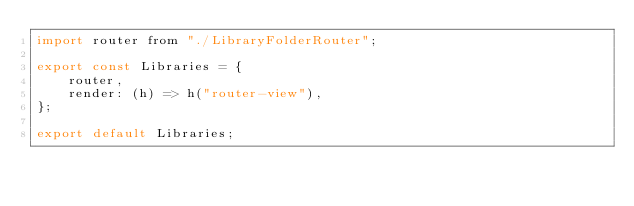<code> <loc_0><loc_0><loc_500><loc_500><_JavaScript_>import router from "./LibraryFolderRouter";

export const Libraries = {
    router,
    render: (h) => h("router-view"),
};

export default Libraries;
</code> 